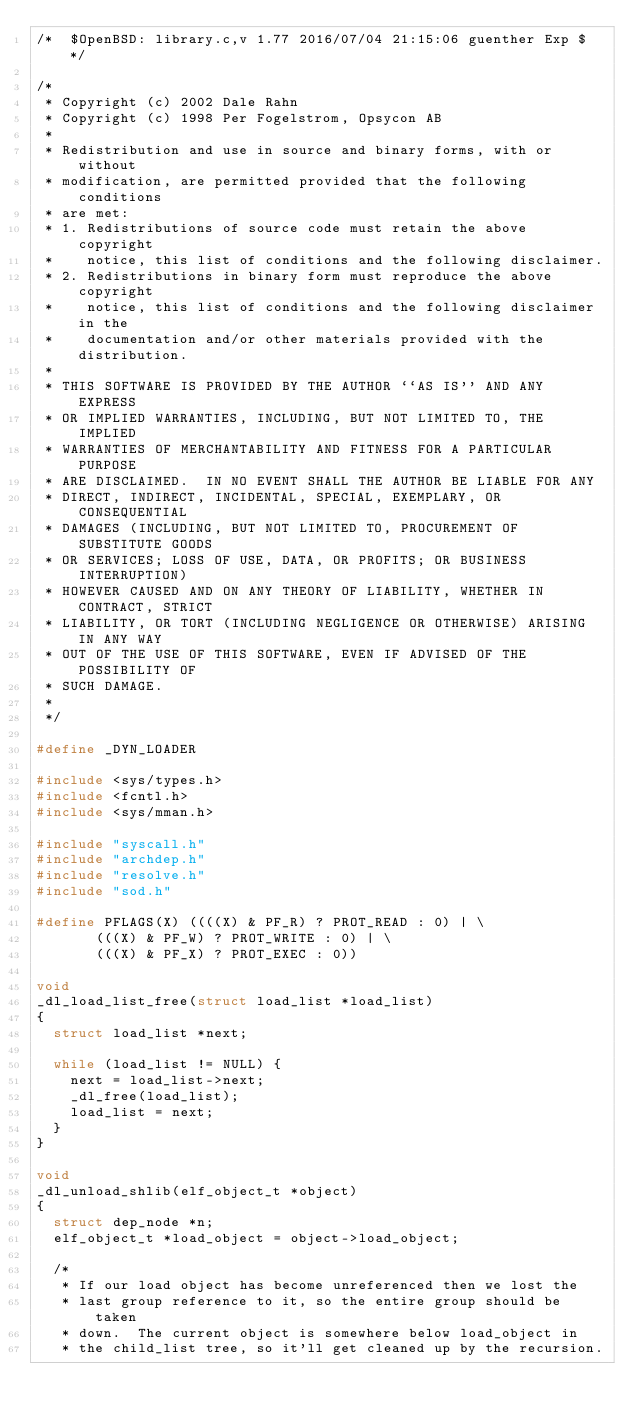<code> <loc_0><loc_0><loc_500><loc_500><_C_>/*	$OpenBSD: library.c,v 1.77 2016/07/04 21:15:06 guenther Exp $ */

/*
 * Copyright (c) 2002 Dale Rahn
 * Copyright (c) 1998 Per Fogelstrom, Opsycon AB
 *
 * Redistribution and use in source and binary forms, with or without
 * modification, are permitted provided that the following conditions
 * are met:
 * 1. Redistributions of source code must retain the above copyright
 *    notice, this list of conditions and the following disclaimer.
 * 2. Redistributions in binary form must reproduce the above copyright
 *    notice, this list of conditions and the following disclaimer in the
 *    documentation and/or other materials provided with the distribution.
 *
 * THIS SOFTWARE IS PROVIDED BY THE AUTHOR ``AS IS'' AND ANY EXPRESS
 * OR IMPLIED WARRANTIES, INCLUDING, BUT NOT LIMITED TO, THE IMPLIED
 * WARRANTIES OF MERCHANTABILITY AND FITNESS FOR A PARTICULAR PURPOSE
 * ARE DISCLAIMED.  IN NO EVENT SHALL THE AUTHOR BE LIABLE FOR ANY
 * DIRECT, INDIRECT, INCIDENTAL, SPECIAL, EXEMPLARY, OR CONSEQUENTIAL
 * DAMAGES (INCLUDING, BUT NOT LIMITED TO, PROCUREMENT OF SUBSTITUTE GOODS
 * OR SERVICES; LOSS OF USE, DATA, OR PROFITS; OR BUSINESS INTERRUPTION)
 * HOWEVER CAUSED AND ON ANY THEORY OF LIABILITY, WHETHER IN CONTRACT, STRICT
 * LIABILITY, OR TORT (INCLUDING NEGLIGENCE OR OTHERWISE) ARISING IN ANY WAY
 * OUT OF THE USE OF THIS SOFTWARE, EVEN IF ADVISED OF THE POSSIBILITY OF
 * SUCH DAMAGE.
 *
 */

#define _DYN_LOADER

#include <sys/types.h>
#include <fcntl.h>
#include <sys/mman.h>

#include "syscall.h"
#include "archdep.h"
#include "resolve.h"
#include "sod.h"

#define PFLAGS(X) ((((X) & PF_R) ? PROT_READ : 0) | \
		   (((X) & PF_W) ? PROT_WRITE : 0) | \
		   (((X) & PF_X) ? PROT_EXEC : 0))

void
_dl_load_list_free(struct load_list *load_list)
{
	struct load_list *next;

	while (load_list != NULL) {
		next = load_list->next;
		_dl_free(load_list);
		load_list = next;
	}
}

void
_dl_unload_shlib(elf_object_t *object)
{
	struct dep_node *n;
	elf_object_t *load_object = object->load_object;

	/*
	 * If our load object has become unreferenced then we lost the
	 * last group reference to it, so the entire group should be taken
	 * down.  The current object is somewhere below load_object in
	 * the child_list tree, so it'll get cleaned up by the recursion.</code> 